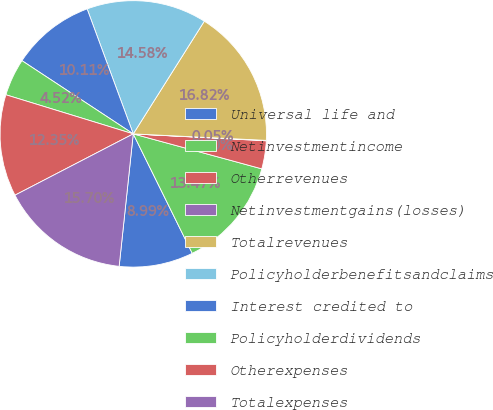<chart> <loc_0><loc_0><loc_500><loc_500><pie_chart><fcel>Universal life and<fcel>Netinvestmentincome<fcel>Otherrevenues<fcel>Netinvestmentgains(losses)<fcel>Totalrevenues<fcel>Policyholderbenefitsandclaims<fcel>Interest credited to<fcel>Policyholderdividends<fcel>Otherexpenses<fcel>Totalexpenses<nl><fcel>8.99%<fcel>13.47%<fcel>3.4%<fcel>0.05%<fcel>16.82%<fcel>14.58%<fcel>10.11%<fcel>4.52%<fcel>12.35%<fcel>15.7%<nl></chart> 